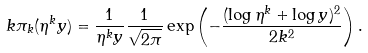Convert formula to latex. <formula><loc_0><loc_0><loc_500><loc_500>k \pi _ { k } ( \eta ^ { k } y ) = \frac { 1 } { \eta ^ { k } y } \frac { 1 } { \sqrt { 2 \pi } } \exp \left ( - \frac { ( \log \eta ^ { k } + \log y ) ^ { 2 } } { 2 k ^ { 2 } } \right ) .</formula> 